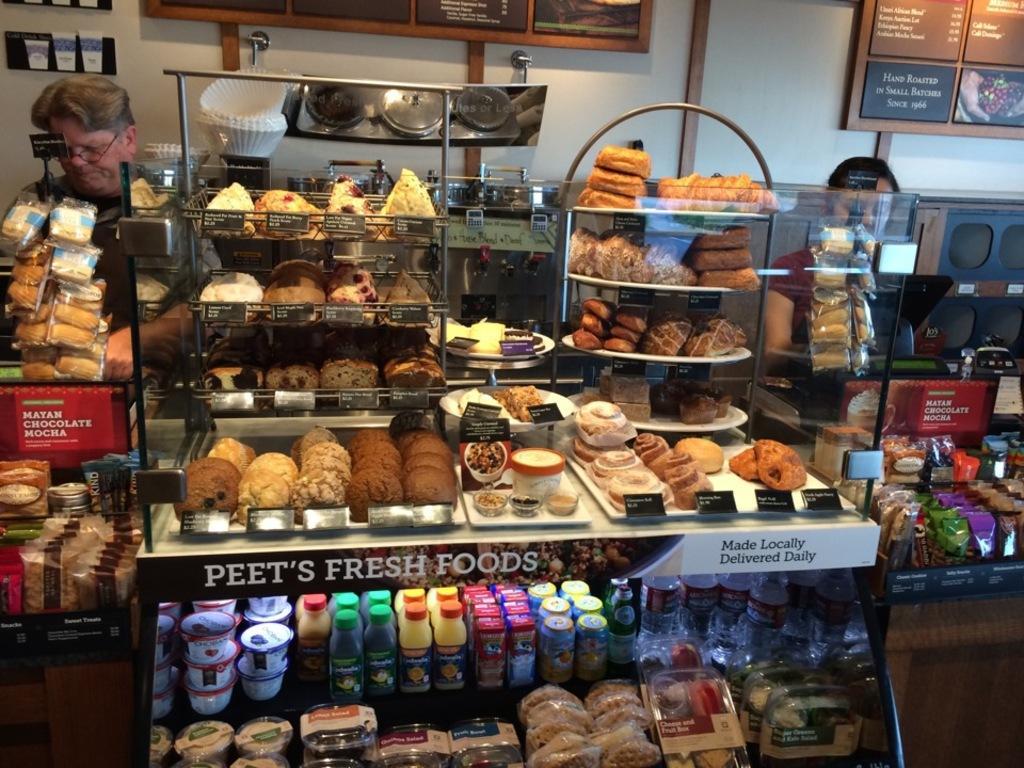In one or two sentences, can you explain what this image depicts? In this picture there are few eatables placed on a stand and there are few other eatables placed on either sides of it and there are two persons standing behind it and there are some other objects in the background. 